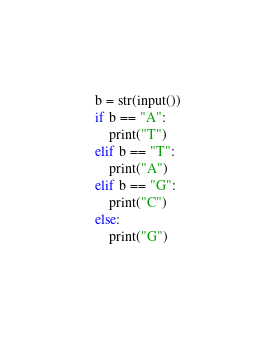Convert code to text. <code><loc_0><loc_0><loc_500><loc_500><_Python_>b = str(input())
if b == "A":
    print("T")
elif b == "T":
    print("A")
elif b == "G":
    print("C")
else:
    print("G")</code> 